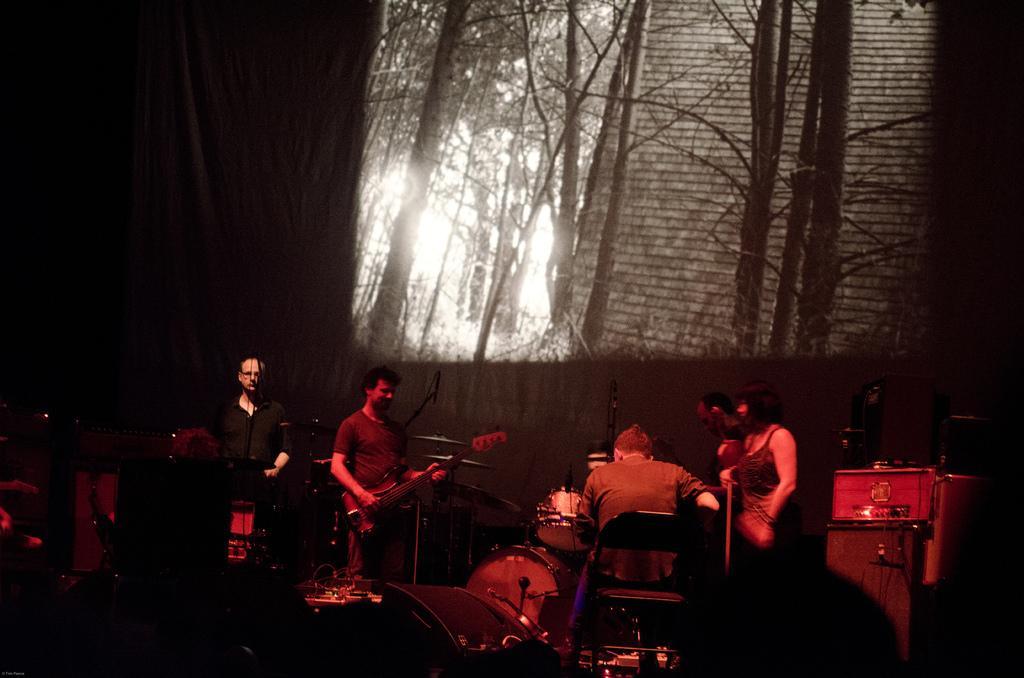How would you summarize this image in a sentence or two? There are people playing musical instruments and we can see devices. We can see screen. In the background it is dark. 